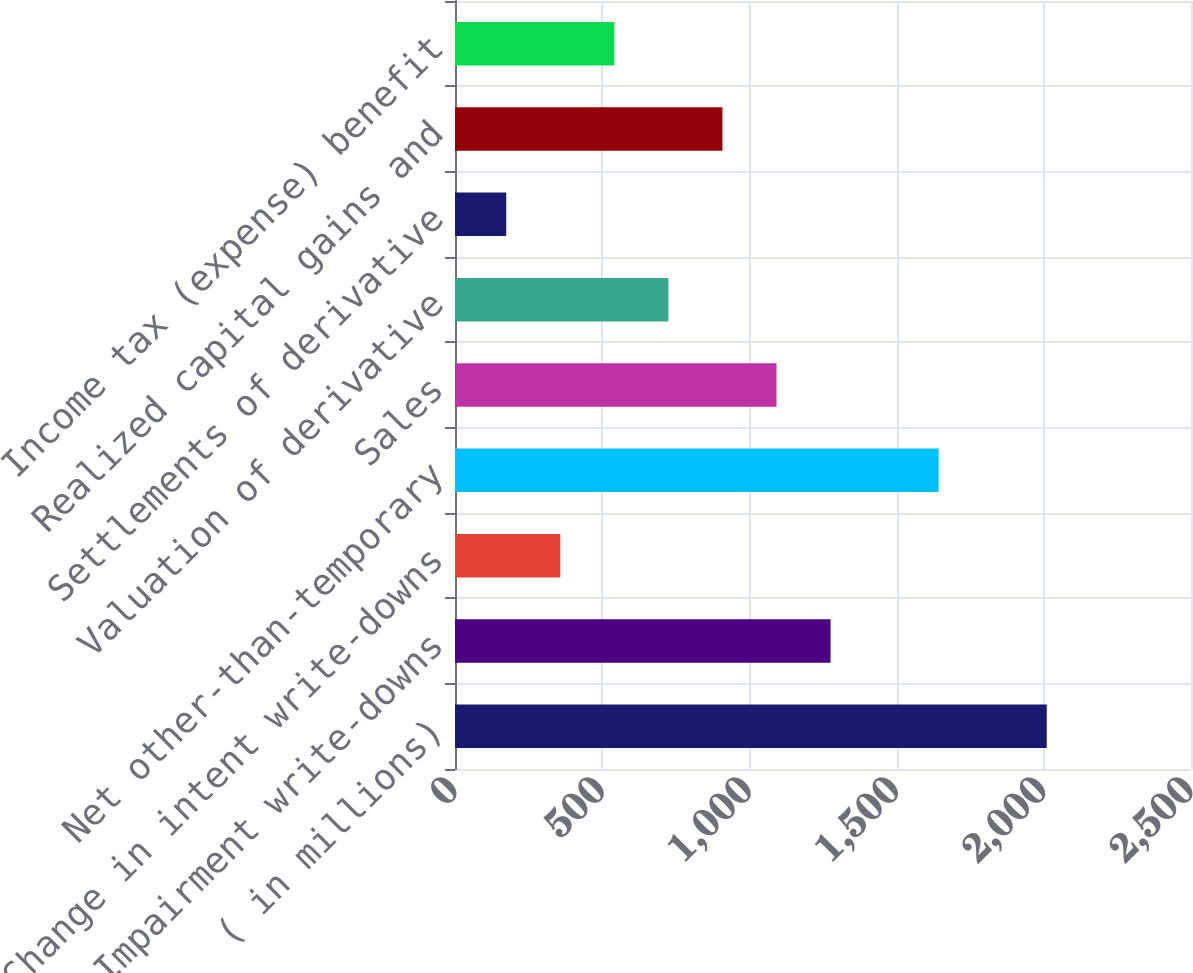Convert chart to OTSL. <chart><loc_0><loc_0><loc_500><loc_500><bar_chart><fcel>( in millions)<fcel>Impairment write-downs<fcel>Change in intent write-downs<fcel>Net other-than-temporary<fcel>Sales<fcel>Valuation of derivative<fcel>Settlements of derivative<fcel>Realized capital gains and<fcel>Income tax (expense) benefit<nl><fcel>2010<fcel>1275.6<fcel>357.6<fcel>1642.8<fcel>1092<fcel>724.8<fcel>174<fcel>908.4<fcel>541.2<nl></chart> 